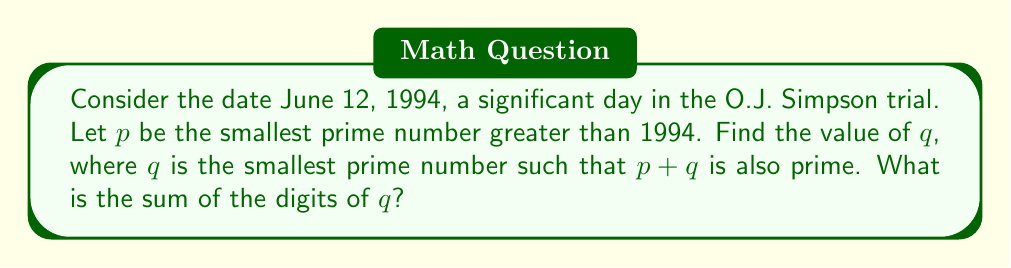Can you solve this math problem? Let's approach this step-by-step:

1) First, we need to find $p$, the smallest prime number greater than 1994.
   
   1997 is the first prime number after 1994.
   
   So, $p = 1997$

2) Now, we need to find $q$, the smallest prime number such that $p + q$ is also prime.

   Let's start checking from the smallest prime number:

   $1997 + 2 = 1999$ (not prime)
   $1997 + 3 = 2000$ (not prime)
   $1997 + 5 = 2002$ (not prime)
   $1997 + 7 = 2004$ (not prime)
   $1997 + 11 = 2008$ (not prime)
   $1997 + 13 = 2010$ (not prime)
   $1997 + 17 = 2014$ (not prime)
   $1997 + 19 = 2016$ (not prime)
   $1997 + 23 = 2020$ (not prime)
   $1997 + 29 = 2026$ (not prime)
   $1997 + 31 = 2028$ (not prime)
   $1997 + 37 = 2034$ (not prime)
   $1997 + 41 = 2038$ (prime)

   We stop here because $2038$ is prime.

3) Therefore, $q = 41$

4) Now, we need to sum the digits of $q$:

   $4 + 1 = 5$

Thus, the sum of the digits of $q$ is 5.
Answer: 5 